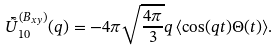<formula> <loc_0><loc_0><loc_500><loc_500>\bar { \tilde { U } } ^ { ( B _ { x y } ) } _ { 1 0 } ( q ) = - 4 \pi \sqrt { \frac { 4 \pi } { 3 } } q \, \langle \cos ( q t ) \Theta ( t ) \rangle .</formula> 